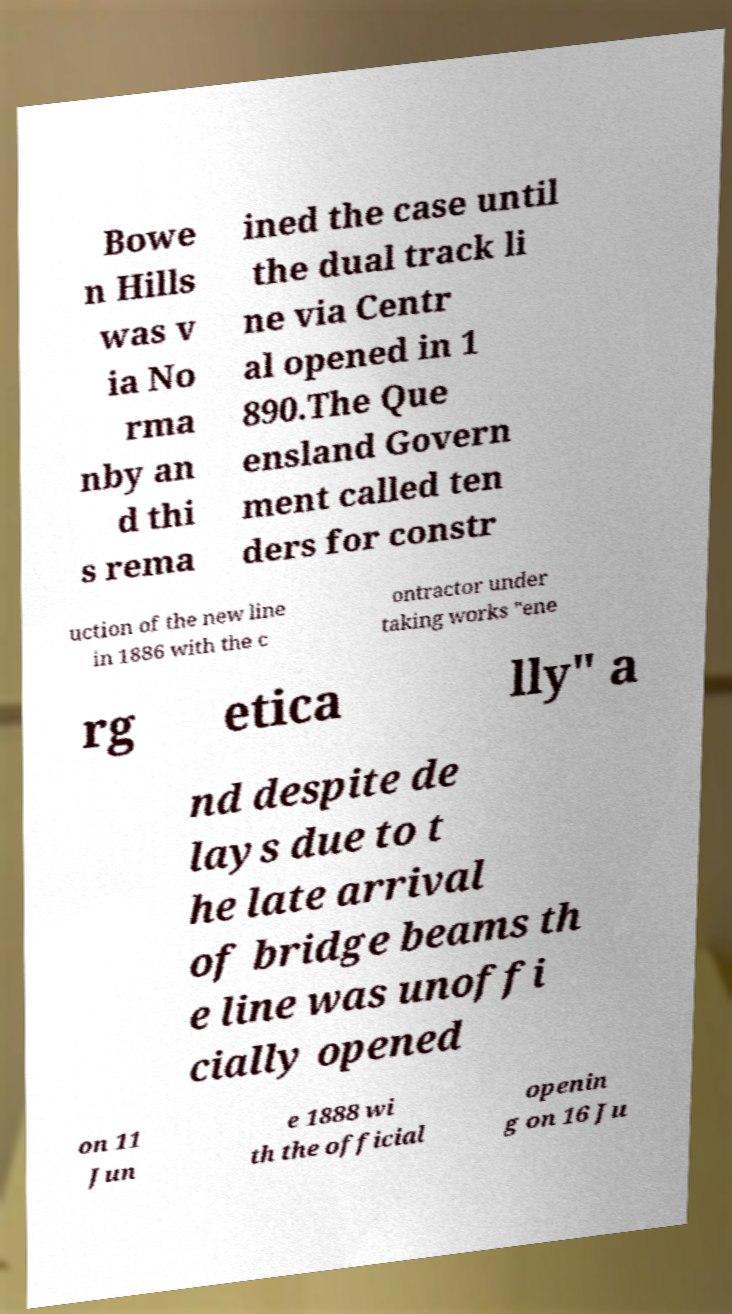Please read and relay the text visible in this image. What does it say? Bowe n Hills was v ia No rma nby an d thi s rema ined the case until the dual track li ne via Centr al opened in 1 890.The Que ensland Govern ment called ten ders for constr uction of the new line in 1886 with the c ontractor under taking works "ene rg etica lly" a nd despite de lays due to t he late arrival of bridge beams th e line was unoffi cially opened on 11 Jun e 1888 wi th the official openin g on 16 Ju 